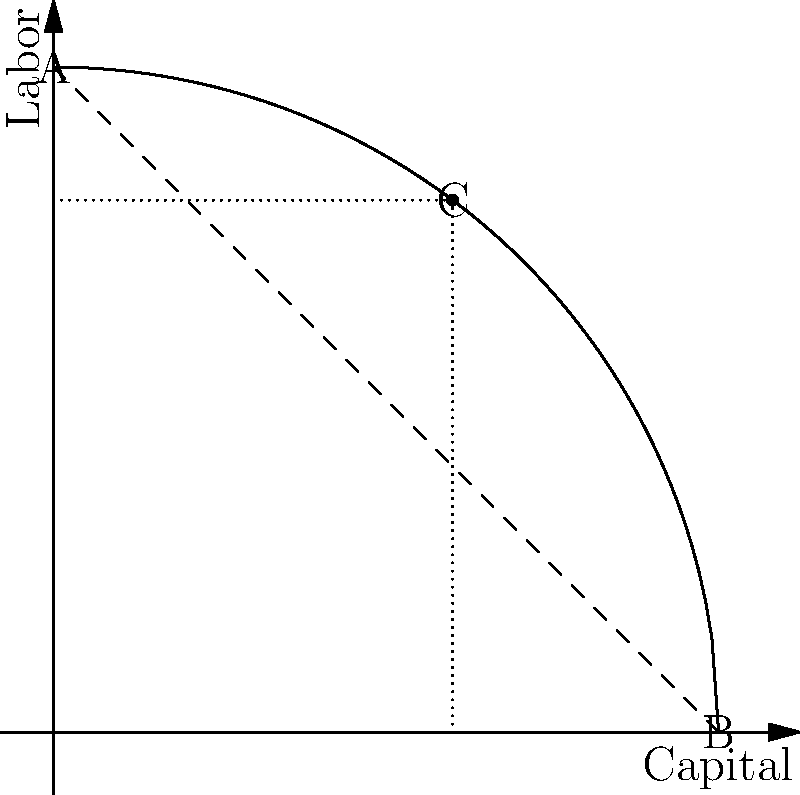In the production possibilities frontier (PPF) shown above, where Capital and Labor are the two factors of production, point C represents a specific allocation. If the angle between the tangent line at point C and the x-axis is $\theta$, and $\tan(\theta) = \frac{4}{3}$, what is the optimal ratio of Labor to Capital at point C? To solve this problem, we'll follow these steps:

1) The slope of the tangent line at point C represents the marginal rate of transformation (MRT) between Labor and Capital.

2) We're given that $\tan(\theta) = \frac{4}{3}$, where $\theta$ is the angle between the tangent line and the x-axis.

3) The slope of the tangent line is equal to $-\tan(\theta)$. The negative sign is because the PPF is downward sloping.

4) Therefore, the MRT at point C is:

   $MRT = -\tan(\theta) = -\frac{4}{3}$

5) At the optimal point, the MRT should equal the ratio of marginal products (MP) of Labor and Capital:

   $MRT = -\frac{MP_L}{MP_C} = -\frac{4}{3}$

6) Rearranging this equation:

   $\frac{MP_L}{MP_C} = \frac{4}{3}$

7) In economic theory, under conditions of perfect competition and constant returns to scale, the ratio of marginal products equals the ratio of inputs:

   $\frac{MP_L}{MP_C} = \frac{L}{C} = \frac{4}{3}$

Therefore, the optimal ratio of Labor to Capital at point C is 4:3 or $\frac{4}{3}$.
Answer: $\frac{4}{3}$ 